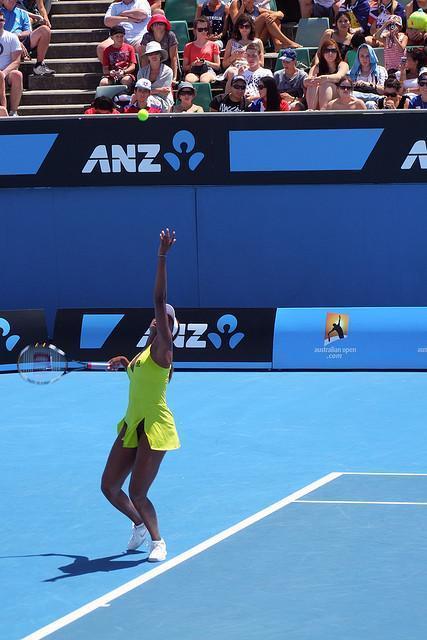How many people are there?
Give a very brief answer. 2. How many blue cars are there?
Give a very brief answer. 0. 